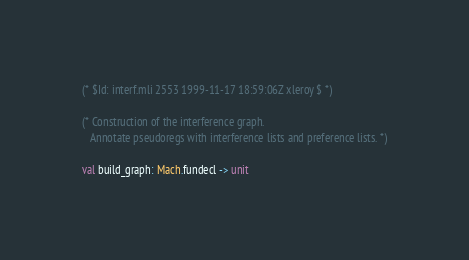<code> <loc_0><loc_0><loc_500><loc_500><_OCaml_>
(* $Id: interf.mli 2553 1999-11-17 18:59:06Z xleroy $ *)

(* Construction of the interference graph.
   Annotate pseudoregs with interference lists and preference lists. *)

val build_graph: Mach.fundecl -> unit
</code> 